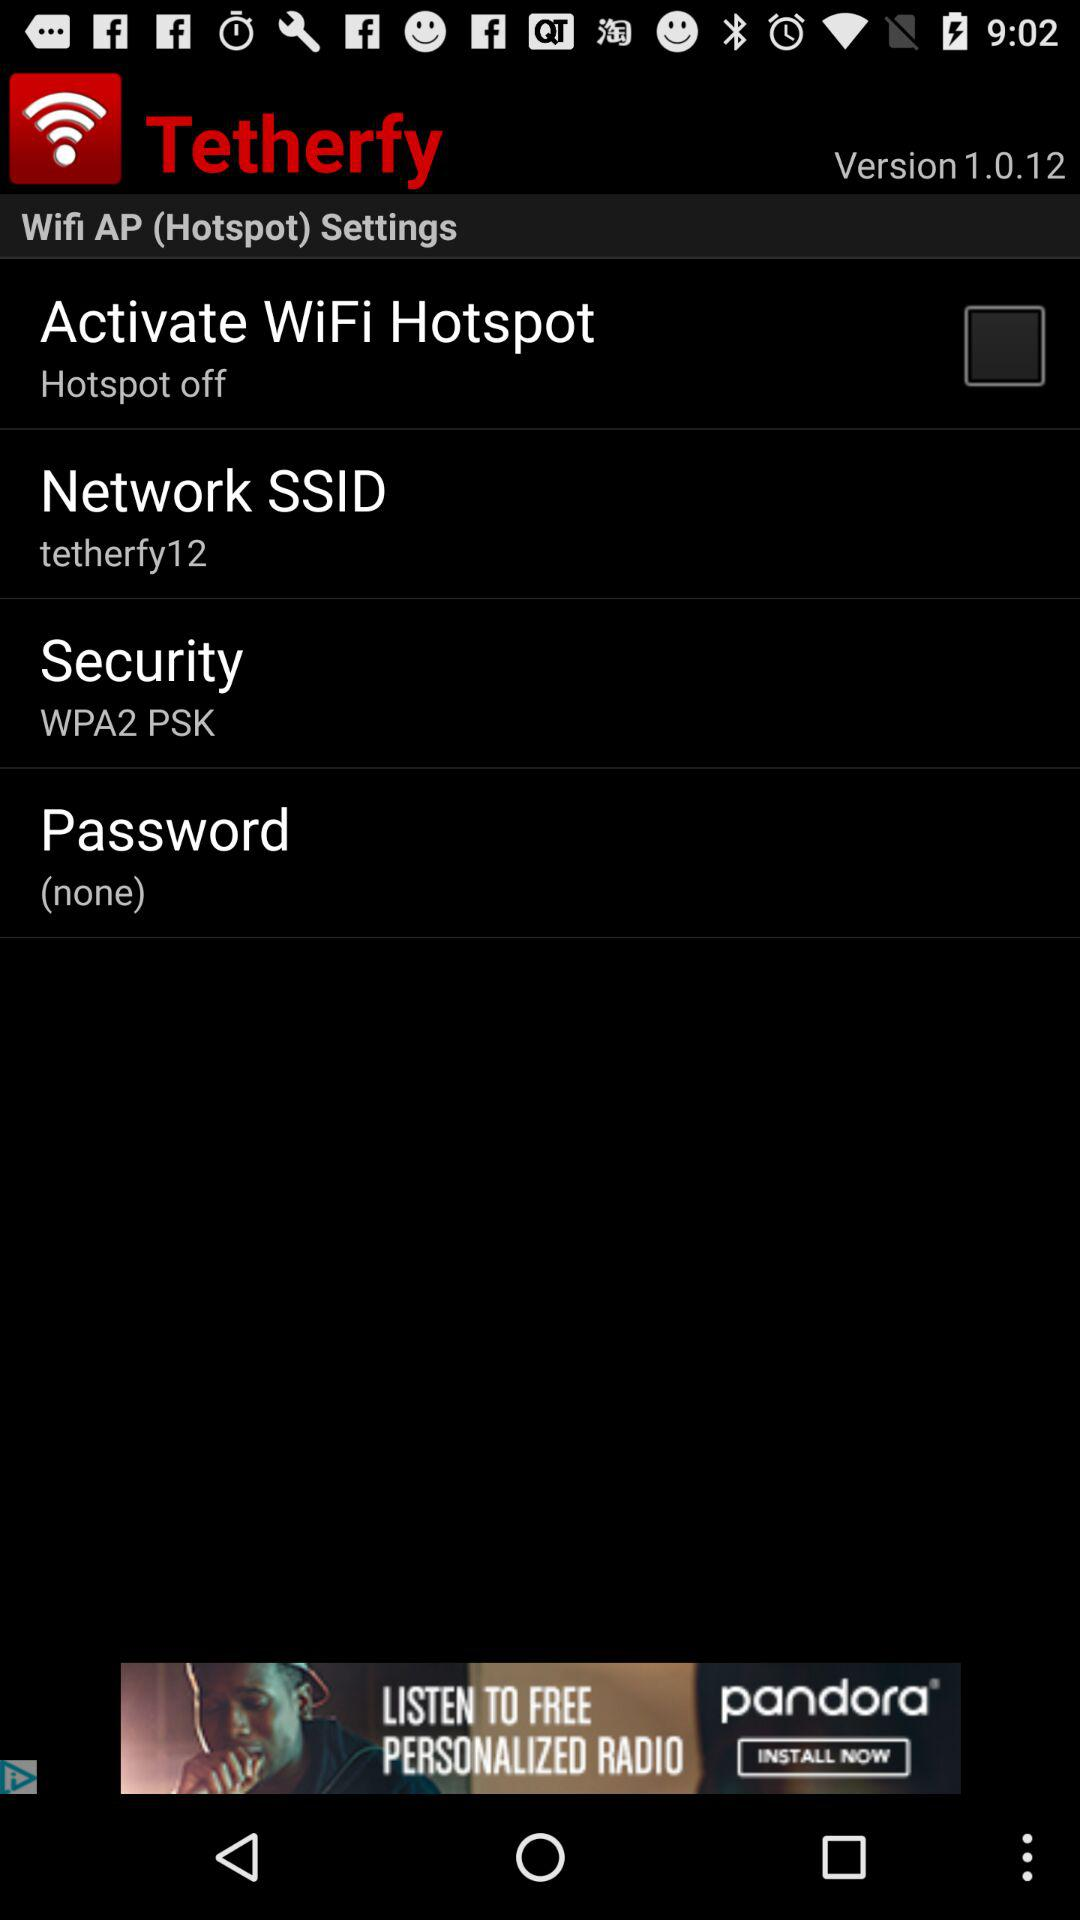What is the name of the application? The name of the application is "Tetherfy". 